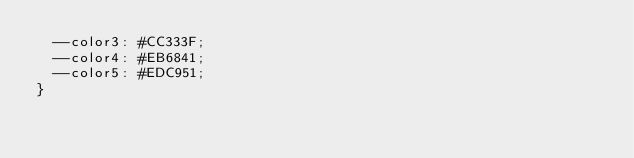Convert code to text. <code><loc_0><loc_0><loc_500><loc_500><_CSS_>  --color3: #CC333F;
  --color4: #EB6841;
  --color5: #EDC951;
}
</code> 